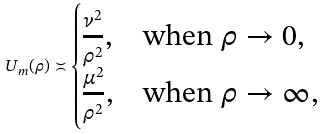Convert formula to latex. <formula><loc_0><loc_0><loc_500><loc_500>U _ { m } ( \rho ) \asymp \begin{cases} \frac { \nu ^ { 2 } } { \rho ^ { 2 } } , & \text {when $\rho\to0$} , \\ \frac { \mu ^ { 2 } } { \rho ^ { 2 } } , & \text {when $\rho\to\infty$} , \end{cases}</formula> 